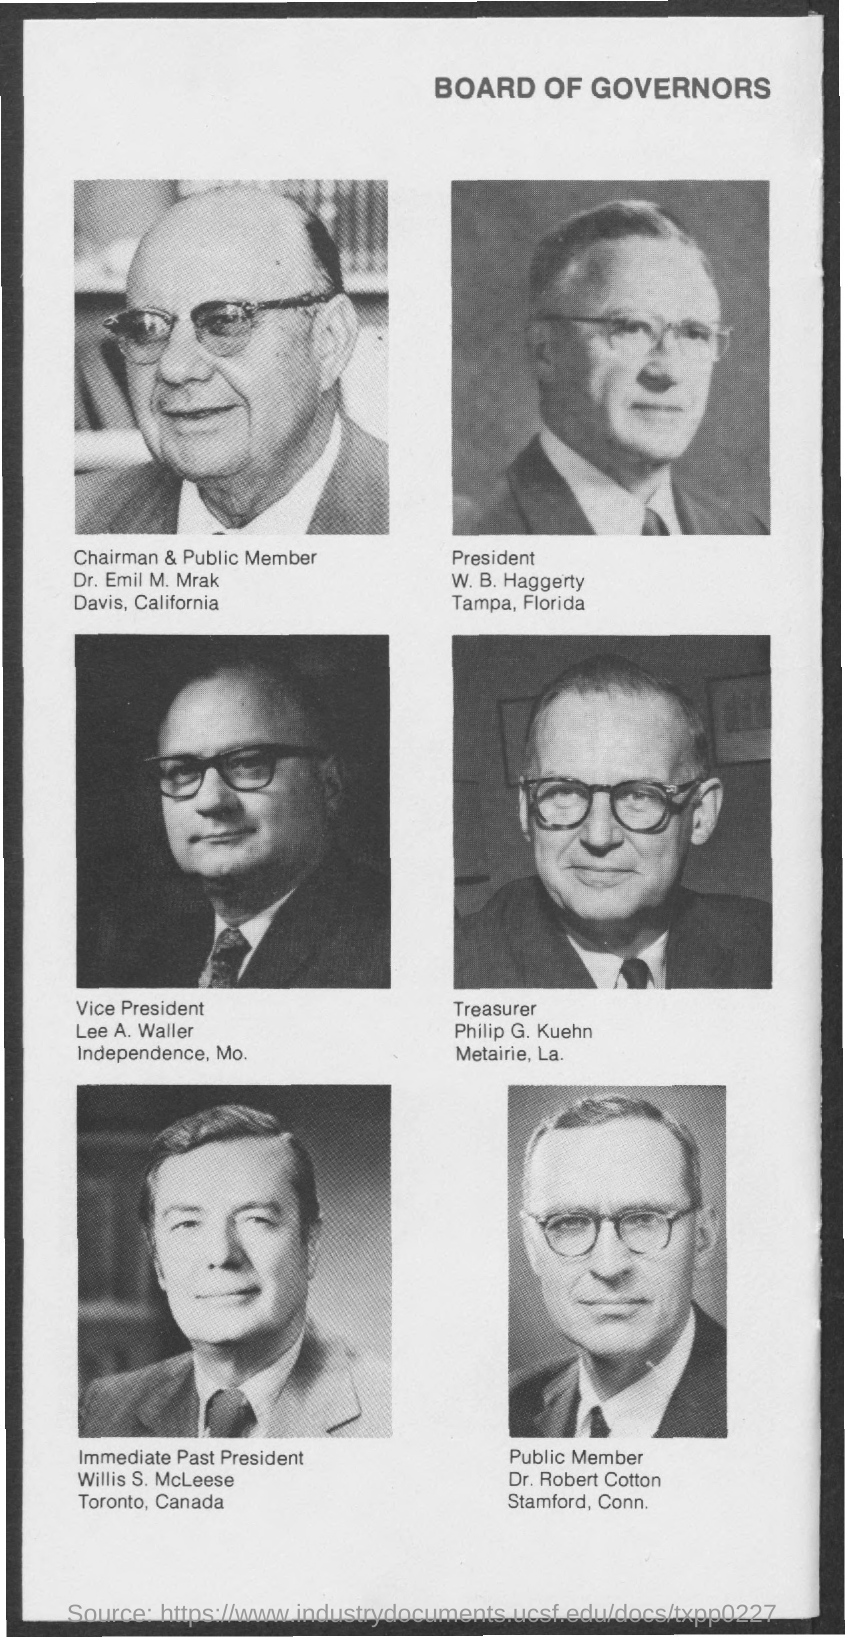What is the name of chairman  & public member ?
Provide a short and direct response. Dr. emil m. mrak. What is the name of president mentioned ?
Offer a terse response. W . B. Haggerty. What is the name of the vice president ?
Give a very brief answer. Lee a. waller. What is the name of the treasurer ?
Your answer should be compact. Philip g. kuehn. What is the name of immediate past president ?
Your answer should be very brief. Willis S. McLeese. What is the name of the public member mentioned ?
Keep it short and to the point. Dr. Robert Cotton. 